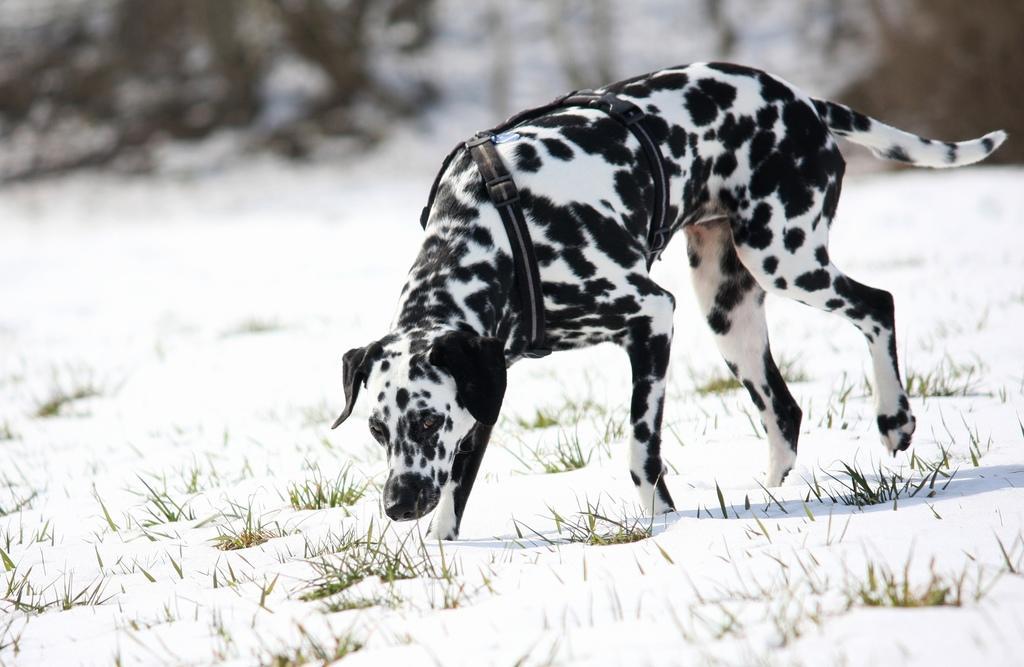Can you describe this image briefly? In this image we can see one dog with belt walking on the ground, some grass on the ground, the ground is full of snow and the background is blurred. 